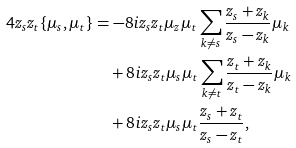Convert formula to latex. <formula><loc_0><loc_0><loc_500><loc_500>4 z _ { s } z _ { t } \{ \mu _ { s } , \mu _ { t } \} & = - 8 i z _ { s } z _ { t } \mu _ { z } \mu _ { t } \sum _ { k \neq s } \frac { z _ { s } + z _ { k } } { z _ { s } - z _ { k } } \mu _ { k } \\ & \quad + 8 i z _ { s } z _ { t } \mu _ { s } \mu _ { t } \sum _ { k \neq t } \frac { z _ { t } + z _ { k } } { z _ { t } - z _ { k } } \mu _ { k } \\ & \quad + 8 i z _ { s } z _ { t } \mu _ { s } \mu _ { t } \frac { z _ { s } + z _ { t } } { z _ { s } - z _ { t } } ,</formula> 